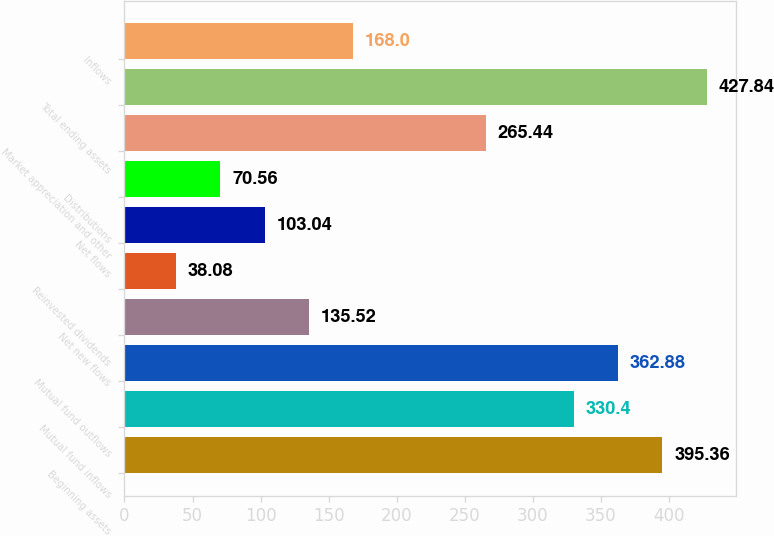Convert chart to OTSL. <chart><loc_0><loc_0><loc_500><loc_500><bar_chart><fcel>Beginning assets<fcel>Mutual fund inflows<fcel>Mutual fund outflows<fcel>Net new flows<fcel>Reinvested dividends<fcel>Net flows<fcel>Distributions<fcel>Market appreciation and other<fcel>Total ending assets<fcel>Inflows<nl><fcel>395.36<fcel>330.4<fcel>362.88<fcel>135.52<fcel>38.08<fcel>103.04<fcel>70.56<fcel>265.44<fcel>427.84<fcel>168<nl></chart> 